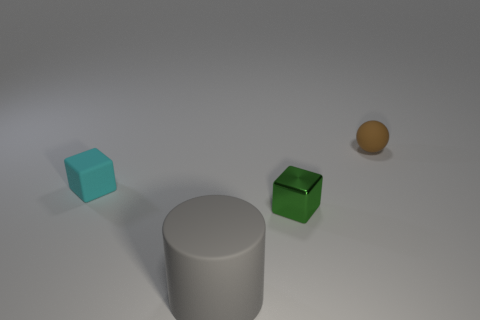Add 2 rubber objects. How many objects exist? 6 Subtract all cyan blocks. How many blocks are left? 1 Subtract all green cylinders. Subtract all red blocks. How many cylinders are left? 1 Subtract 1 cyan blocks. How many objects are left? 3 Subtract all balls. How many objects are left? 3 Subtract 1 blocks. How many blocks are left? 1 Subtract all gray rubber cylinders. Subtract all brown matte balls. How many objects are left? 2 Add 3 green metallic cubes. How many green metallic cubes are left? 4 Add 2 purple matte spheres. How many purple matte spheres exist? 2 